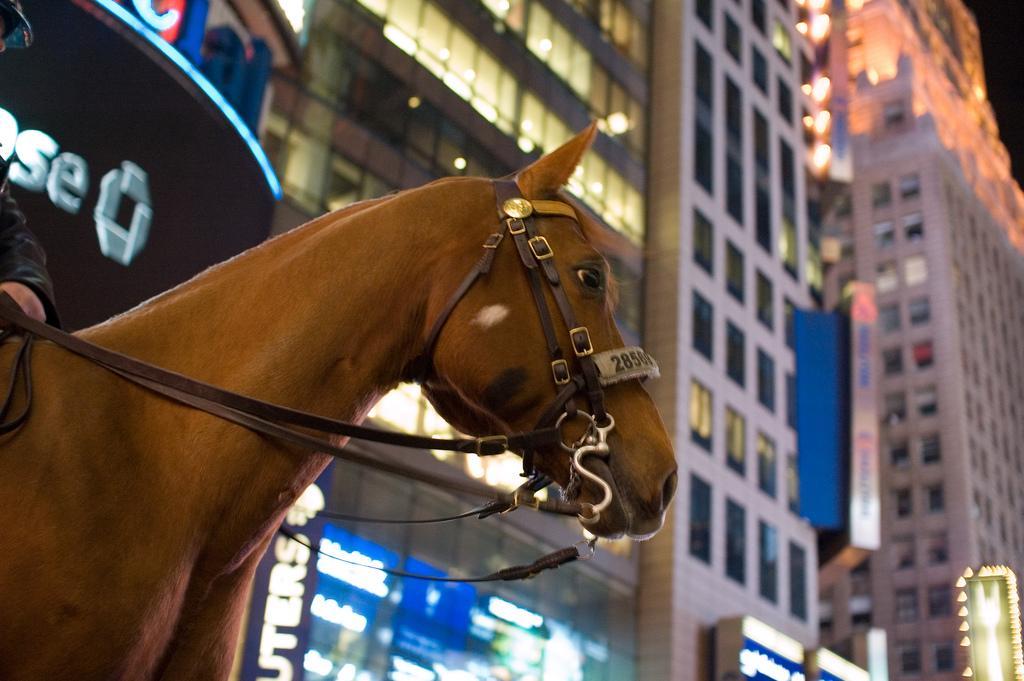Can you describe this image briefly? In the bottom left side of the image a person is riding horse. Behind the horse there are some buildings. 